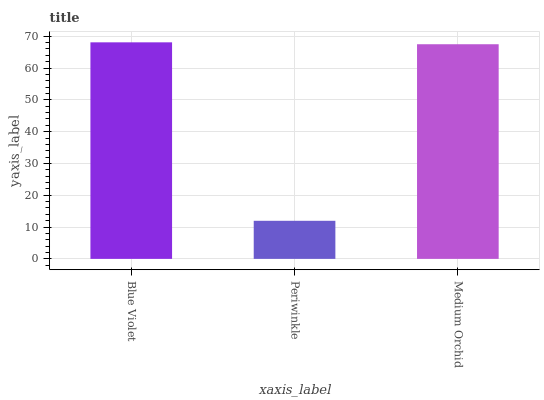Is Periwinkle the minimum?
Answer yes or no. Yes. Is Blue Violet the maximum?
Answer yes or no. Yes. Is Medium Orchid the minimum?
Answer yes or no. No. Is Medium Orchid the maximum?
Answer yes or no. No. Is Medium Orchid greater than Periwinkle?
Answer yes or no. Yes. Is Periwinkle less than Medium Orchid?
Answer yes or no. Yes. Is Periwinkle greater than Medium Orchid?
Answer yes or no. No. Is Medium Orchid less than Periwinkle?
Answer yes or no. No. Is Medium Orchid the high median?
Answer yes or no. Yes. Is Medium Orchid the low median?
Answer yes or no. Yes. Is Blue Violet the high median?
Answer yes or no. No. Is Periwinkle the low median?
Answer yes or no. No. 